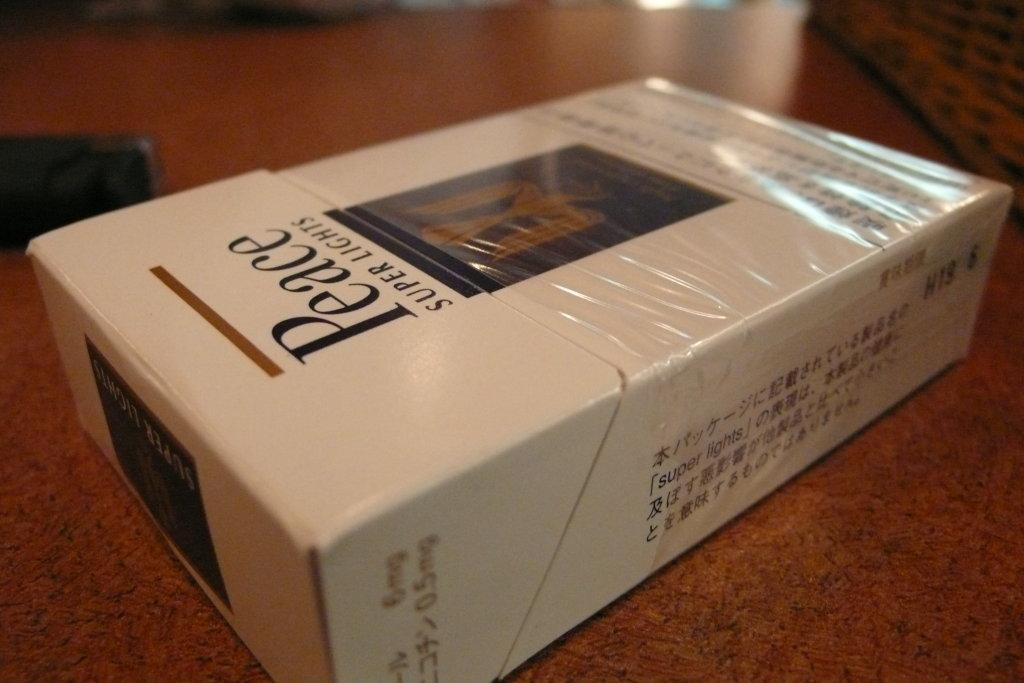<image>
Create a compact narrative representing the image presented. A pack of peace super light cigarettes on the table. 